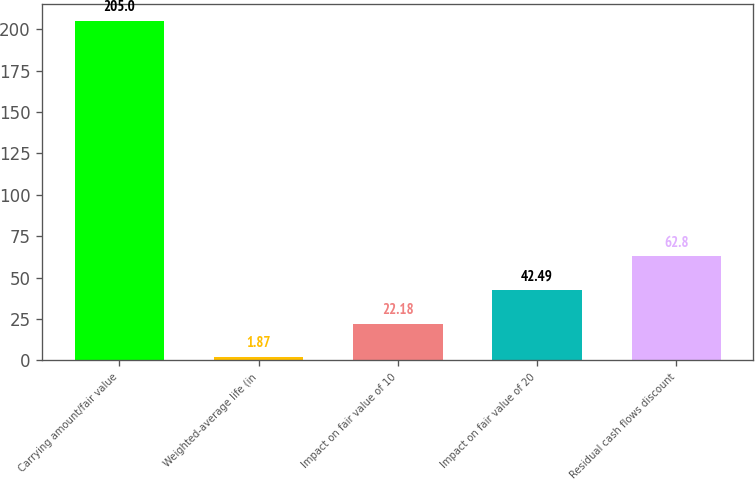Convert chart. <chart><loc_0><loc_0><loc_500><loc_500><bar_chart><fcel>Carrying amount/fair value<fcel>Weighted-average life (in<fcel>Impact on fair value of 10<fcel>Impact on fair value of 20<fcel>Residual cash flows discount<nl><fcel>205<fcel>1.87<fcel>22.18<fcel>42.49<fcel>62.8<nl></chart> 